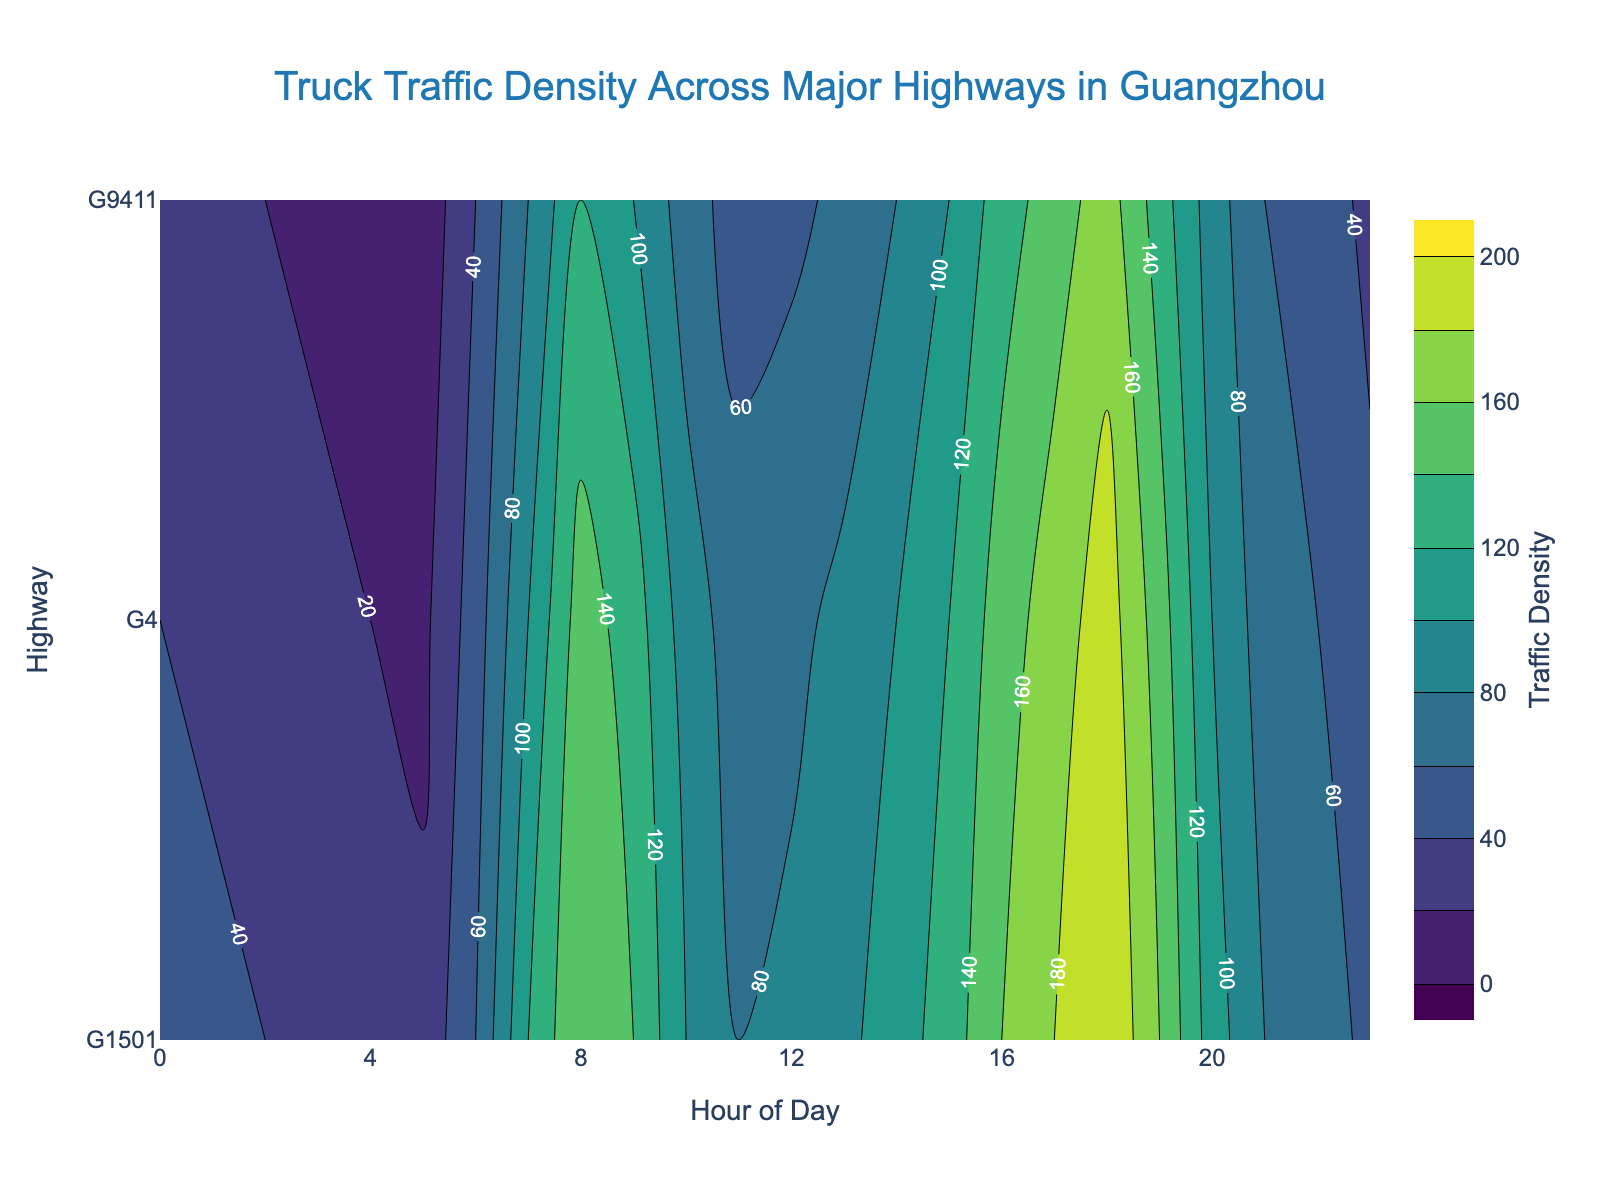What's the title of the figure? The title of the figure is centrally positioned at the top and is styled with a specific font and color.
Answer: Truck Traffic Density Across Major Highways in Guangzhou Which hour of the day corresponds to the highest traffic density on G1501? To determine this, look for the highest contour level label along the G1501 highway row. The peak traffic density is seen at 18:00, with a value of 200.
Answer: 18:00 During which hours does G9411 have the lowest traffic density? Identify the lowest contour levels for the G9411 highway. The lowest traffic density values are at 05:00 with a density of 5.
Answer: 05:00 How does the traffic density on G4 at 09:00 compare to that on G9411 at the same hour? Compare the contour labels for both G4 and G9411 at 09:00. The density on G4 is 130, whereas on G9411 it is 100.
Answer: Higher on G4 What is the range of traffic density values shown in the color bar? Observe the values marked at the start and end of the color bar to the right of the contour plot. The range is 0 to 200.
Answer: 0 to 200 What's the average traffic density on G1501 from 12:00 to 14:00? Find the traffic densities for G1501 at 12:00, 13:00, and 14:00 which are 85, 95, and 110 respectively. Compute the average: (85 + 95 + 110) / 3 = 96.67.
Answer: 96.67 Which highway experiences the most significant change in traffic density between 06:00 and 18:00? Calculate the difference in traffic density at 06:00 and 18:00 for all highways. G1501 goes from 60 to 200 (200-60=140), G4 from 50 to 190 (190-50=140), and G9411 from 40 to 170 (170-40=130). Both G1501 and G4 show a change of 140.
Answer: G1501 and G4 At what times is the traffic density highest on any highway? Identify the contour labels where densities are at peak, 200, which occur at 18:00 for G1501 and 18:00 for G4.
Answer: 18:00 